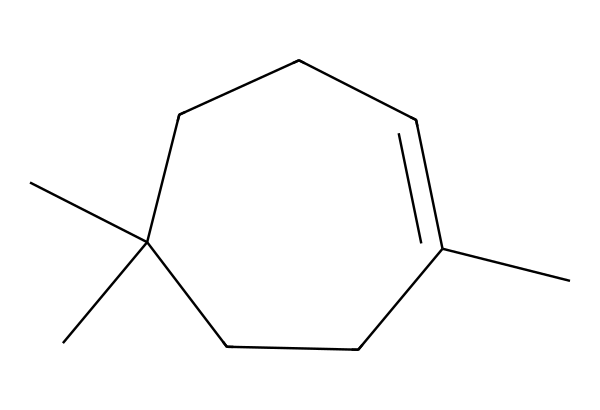What is the molecular formula of the compound represented by the SMILES? Analyzing the structure derived from the SMILES, we can count the carbon (C) and hydrogen (H) atoms. There are 15 carbon atoms and 28 hydrogen atoms based on the connections seen in the structure. Therefore, the molecular formula is C15H28.
Answer: C15H28 How many rings are present in the structure? Upon examining the given chemical structure, there are no closed loops or rings observable. The structure is acyclic, thus indicating that there are zero rings present.
Answer: zero What type of compound is represented by this SMILES? The structure contains carbon and does not show the presence of nitrogen or any functional group indicative of nitriles, making it a limonene derivative often found in flavor compounds. It is classified as a terpene.
Answer: terpene What is the degree of unsaturation in the compound? The degree of unsaturation can be calculated using the formula: (number of rings + number of double bonds). Given that there are no rings and only one double bond in the structure, the degree of unsaturation is one.
Answer: one Is there any presence of functional groups in this structure? Analyzing the displayed structure, there are no visible functional groups such as hydroxyl, carboxyl, or nitrile groups present. The compound mainly consists of carbon and hydrogen atoms in a hydrocarbon chain without any functional groups.
Answer: none What is the significance of this compound in cheese production? Limonene is known for its citrus aroma and is responsible for some flavor profiles in various cheeses. Its presence can enhance the sensory qualities and overall flavor complexity of cheese.
Answer: enhances flavor 